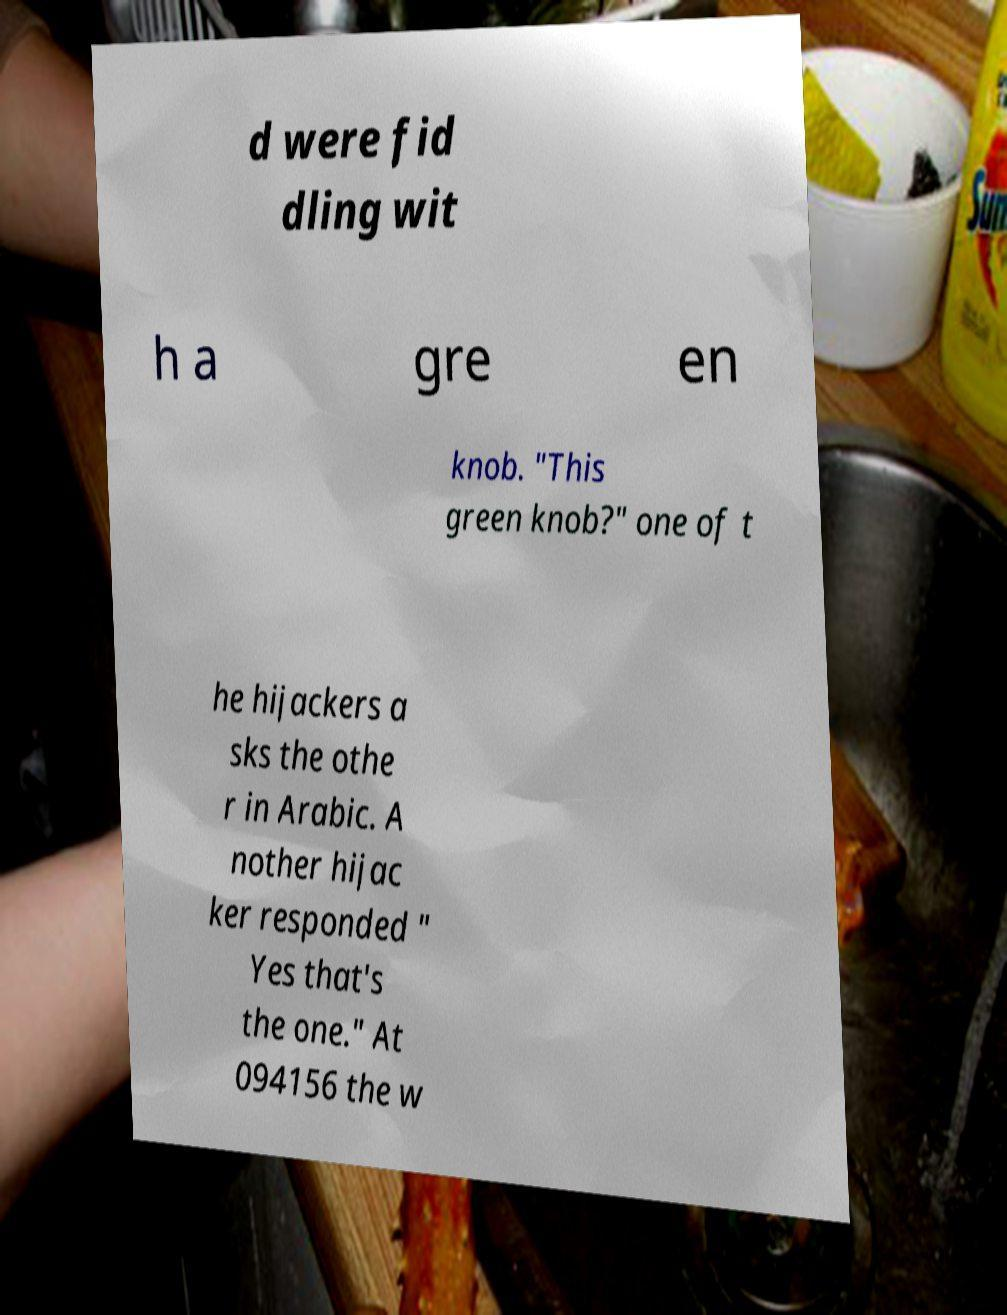Please identify and transcribe the text found in this image. d were fid dling wit h a gre en knob. "This green knob?" one of t he hijackers a sks the othe r in Arabic. A nother hijac ker responded " Yes that's the one." At 094156 the w 